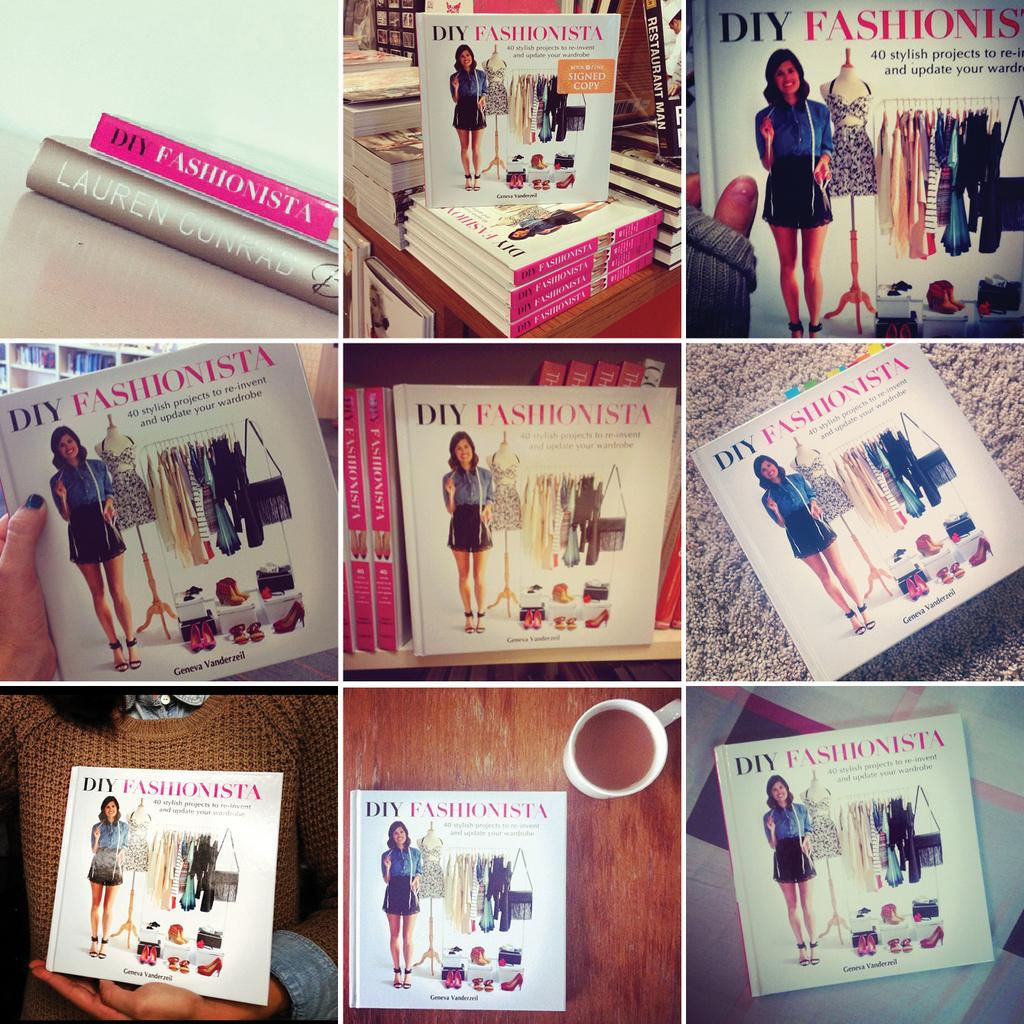<image>
Render a clear and concise summary of the photo. The title of this book is called "DIY Fashionista." 